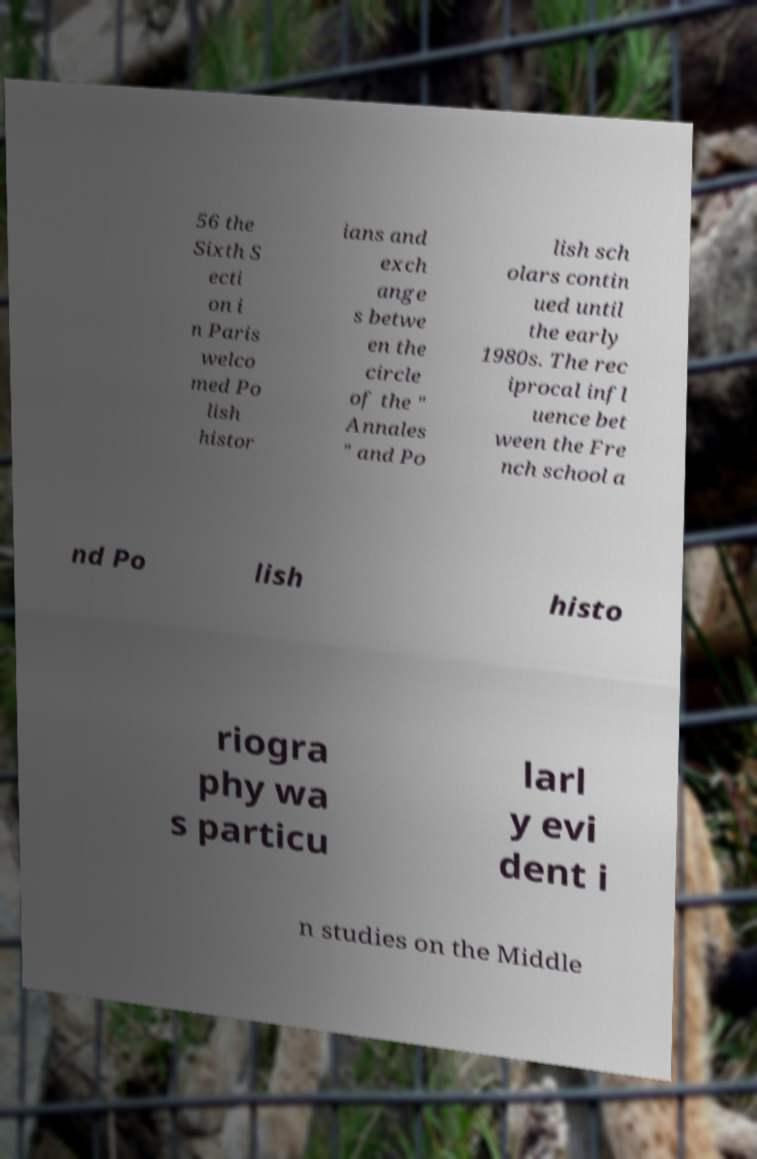There's text embedded in this image that I need extracted. Can you transcribe it verbatim? 56 the Sixth S ecti on i n Paris welco med Po lish histor ians and exch ange s betwe en the circle of the " Annales " and Po lish sch olars contin ued until the early 1980s. The rec iprocal infl uence bet ween the Fre nch school a nd Po lish histo riogra phy wa s particu larl y evi dent i n studies on the Middle 